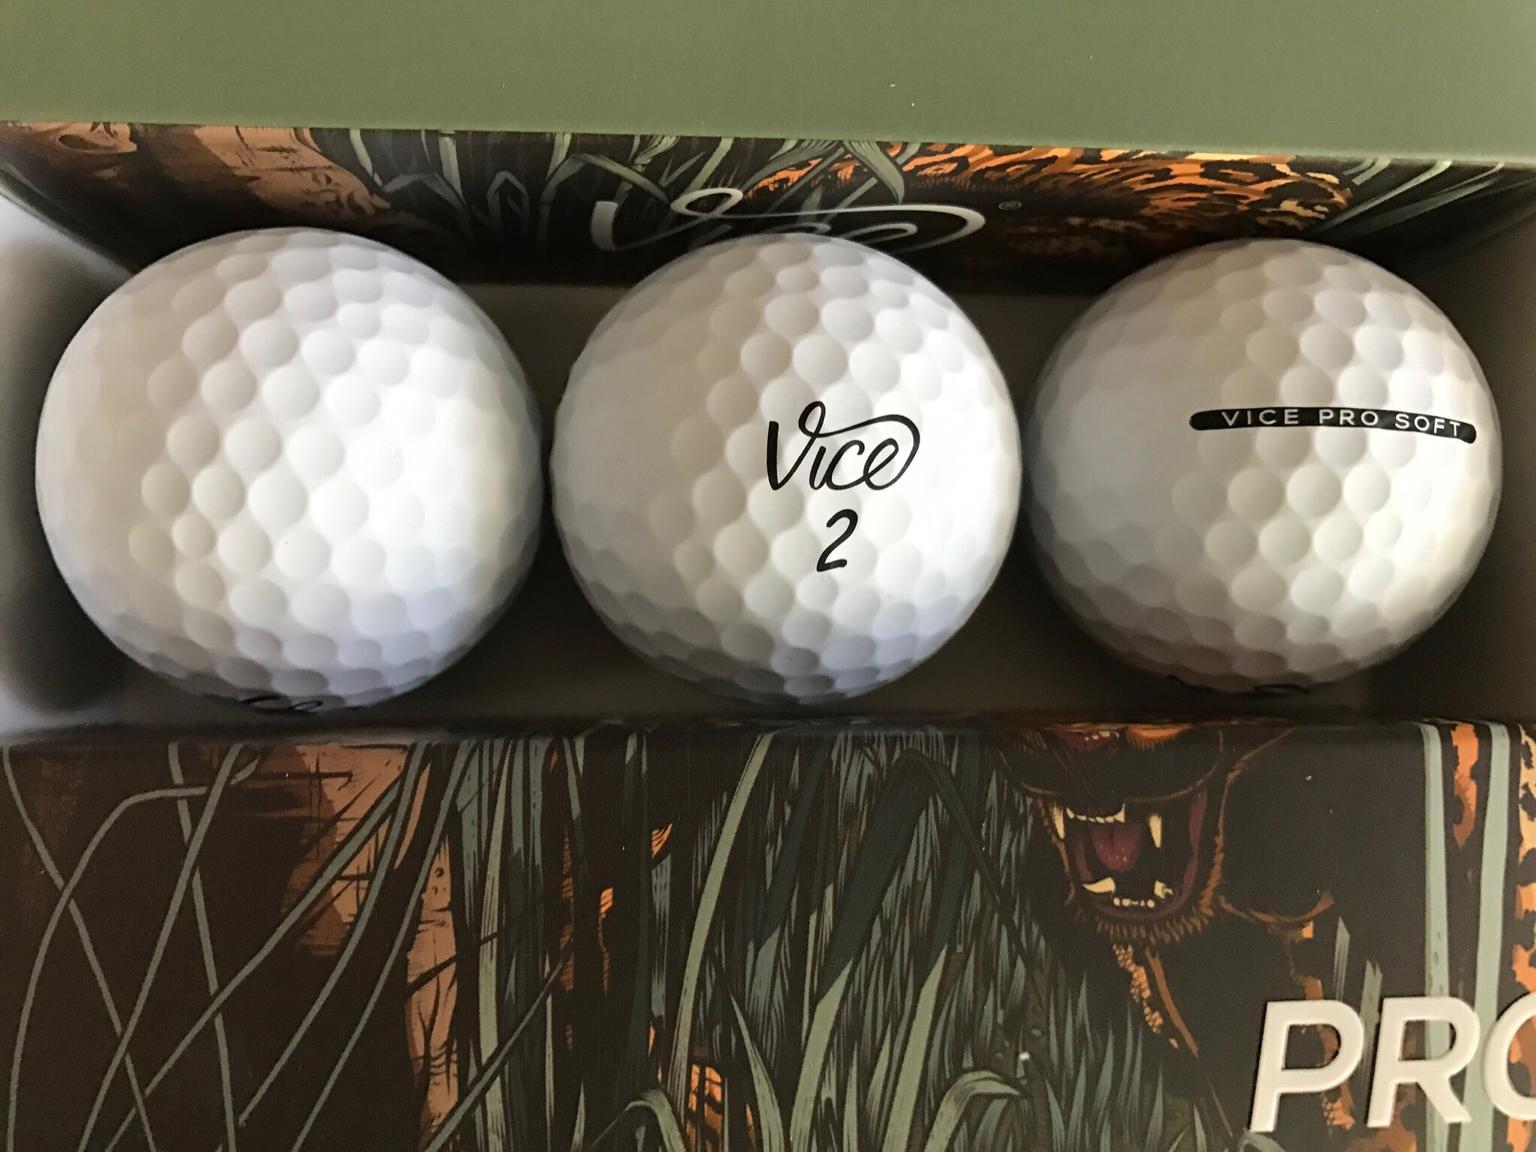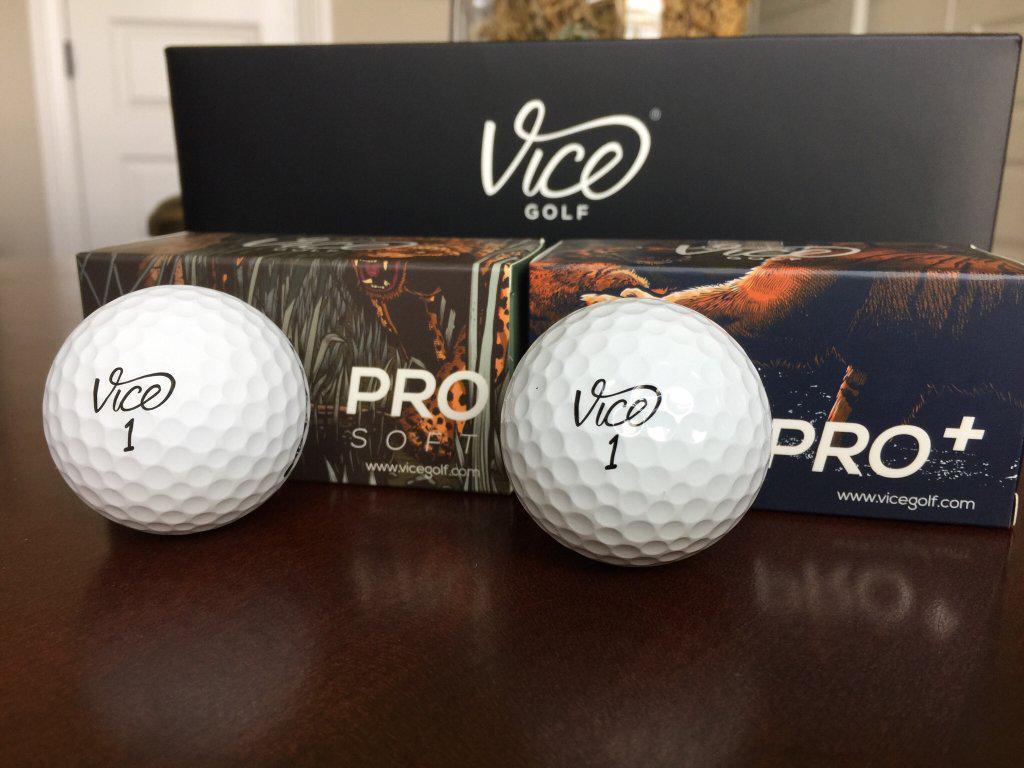The first image is the image on the left, the second image is the image on the right. For the images displayed, is the sentence "Both pictures contain what appear to be the same single golf ball." factually correct? Answer yes or no. No. The first image is the image on the left, the second image is the image on the right. For the images shown, is this caption "There are both green and white golfballs." true? Answer yes or no. No. 